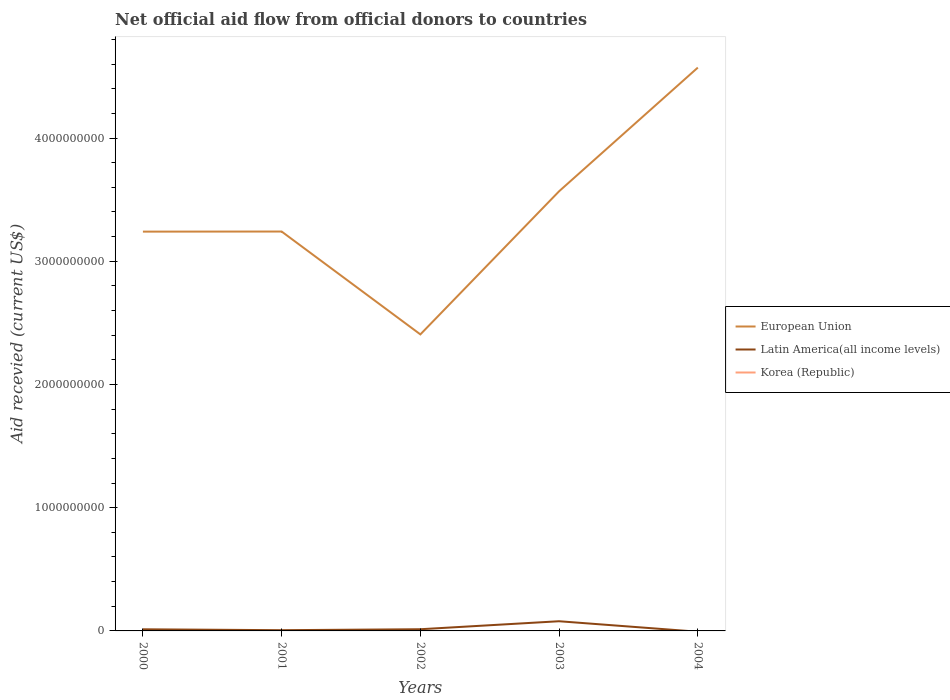Does the line corresponding to Korea (Republic) intersect with the line corresponding to European Union?
Ensure brevity in your answer.  No. Is the number of lines equal to the number of legend labels?
Your answer should be very brief. No. What is the total total aid received in European Union in the graph?
Keep it short and to the point. -1.33e+09. What is the difference between the highest and the second highest total aid received in Latin America(all income levels)?
Give a very brief answer. 7.86e+07. Is the total aid received in European Union strictly greater than the total aid received in Korea (Republic) over the years?
Your answer should be compact. No. How many lines are there?
Provide a succinct answer. 2. How many years are there in the graph?
Ensure brevity in your answer.  5. What is the difference between two consecutive major ticks on the Y-axis?
Keep it short and to the point. 1.00e+09. Are the values on the major ticks of Y-axis written in scientific E-notation?
Keep it short and to the point. No. How many legend labels are there?
Keep it short and to the point. 3. How are the legend labels stacked?
Offer a terse response. Vertical. What is the title of the graph?
Ensure brevity in your answer.  Net official aid flow from official donors to countries. Does "Thailand" appear as one of the legend labels in the graph?
Make the answer very short. No. What is the label or title of the X-axis?
Offer a very short reply. Years. What is the label or title of the Y-axis?
Provide a succinct answer. Aid recevied (current US$). What is the Aid recevied (current US$) of European Union in 2000?
Your answer should be very brief. 3.24e+09. What is the Aid recevied (current US$) of Latin America(all income levels) in 2000?
Make the answer very short. 1.31e+07. What is the Aid recevied (current US$) in European Union in 2001?
Keep it short and to the point. 3.24e+09. What is the Aid recevied (current US$) in Latin America(all income levels) in 2001?
Make the answer very short. 5.97e+06. What is the Aid recevied (current US$) in European Union in 2002?
Keep it short and to the point. 2.41e+09. What is the Aid recevied (current US$) in Latin America(all income levels) in 2002?
Make the answer very short. 1.37e+07. What is the Aid recevied (current US$) in Korea (Republic) in 2002?
Offer a terse response. 0. What is the Aid recevied (current US$) of European Union in 2003?
Your answer should be very brief. 3.57e+09. What is the Aid recevied (current US$) in Latin America(all income levels) in 2003?
Make the answer very short. 7.86e+07. What is the Aid recevied (current US$) of Korea (Republic) in 2003?
Your answer should be very brief. 0. What is the Aid recevied (current US$) of European Union in 2004?
Provide a short and direct response. 4.57e+09. What is the Aid recevied (current US$) in Latin America(all income levels) in 2004?
Provide a succinct answer. 0. What is the Aid recevied (current US$) of Korea (Republic) in 2004?
Your answer should be very brief. 0. Across all years, what is the maximum Aid recevied (current US$) of European Union?
Provide a short and direct response. 4.57e+09. Across all years, what is the maximum Aid recevied (current US$) in Latin America(all income levels)?
Ensure brevity in your answer.  7.86e+07. Across all years, what is the minimum Aid recevied (current US$) of European Union?
Give a very brief answer. 2.41e+09. What is the total Aid recevied (current US$) in European Union in the graph?
Offer a terse response. 1.70e+1. What is the total Aid recevied (current US$) in Latin America(all income levels) in the graph?
Your answer should be compact. 1.11e+08. What is the total Aid recevied (current US$) in Korea (Republic) in the graph?
Provide a short and direct response. 0. What is the difference between the Aid recevied (current US$) in European Union in 2000 and that in 2001?
Your response must be concise. -7.70e+05. What is the difference between the Aid recevied (current US$) in Latin America(all income levels) in 2000 and that in 2001?
Offer a very short reply. 7.16e+06. What is the difference between the Aid recevied (current US$) in European Union in 2000 and that in 2002?
Offer a very short reply. 8.34e+08. What is the difference between the Aid recevied (current US$) in Latin America(all income levels) in 2000 and that in 2002?
Your answer should be very brief. -5.80e+05. What is the difference between the Aid recevied (current US$) of European Union in 2000 and that in 2003?
Your answer should be very brief. -3.28e+08. What is the difference between the Aid recevied (current US$) in Latin America(all income levels) in 2000 and that in 2003?
Offer a terse response. -6.54e+07. What is the difference between the Aid recevied (current US$) in European Union in 2000 and that in 2004?
Make the answer very short. -1.33e+09. What is the difference between the Aid recevied (current US$) in European Union in 2001 and that in 2002?
Provide a succinct answer. 8.35e+08. What is the difference between the Aid recevied (current US$) of Latin America(all income levels) in 2001 and that in 2002?
Offer a very short reply. -7.74e+06. What is the difference between the Aid recevied (current US$) in European Union in 2001 and that in 2003?
Provide a short and direct response. -3.27e+08. What is the difference between the Aid recevied (current US$) in Latin America(all income levels) in 2001 and that in 2003?
Make the answer very short. -7.26e+07. What is the difference between the Aid recevied (current US$) in European Union in 2001 and that in 2004?
Give a very brief answer. -1.33e+09. What is the difference between the Aid recevied (current US$) of European Union in 2002 and that in 2003?
Your answer should be compact. -1.16e+09. What is the difference between the Aid recevied (current US$) in Latin America(all income levels) in 2002 and that in 2003?
Your response must be concise. -6.49e+07. What is the difference between the Aid recevied (current US$) of European Union in 2002 and that in 2004?
Make the answer very short. -2.17e+09. What is the difference between the Aid recevied (current US$) of European Union in 2003 and that in 2004?
Provide a succinct answer. -1.00e+09. What is the difference between the Aid recevied (current US$) in European Union in 2000 and the Aid recevied (current US$) in Latin America(all income levels) in 2001?
Provide a short and direct response. 3.23e+09. What is the difference between the Aid recevied (current US$) of European Union in 2000 and the Aid recevied (current US$) of Latin America(all income levels) in 2002?
Provide a succinct answer. 3.23e+09. What is the difference between the Aid recevied (current US$) of European Union in 2000 and the Aid recevied (current US$) of Latin America(all income levels) in 2003?
Offer a very short reply. 3.16e+09. What is the difference between the Aid recevied (current US$) of European Union in 2001 and the Aid recevied (current US$) of Latin America(all income levels) in 2002?
Offer a very short reply. 3.23e+09. What is the difference between the Aid recevied (current US$) in European Union in 2001 and the Aid recevied (current US$) in Latin America(all income levels) in 2003?
Your answer should be very brief. 3.16e+09. What is the difference between the Aid recevied (current US$) in European Union in 2002 and the Aid recevied (current US$) in Latin America(all income levels) in 2003?
Make the answer very short. 2.33e+09. What is the average Aid recevied (current US$) in European Union per year?
Provide a short and direct response. 3.41e+09. What is the average Aid recevied (current US$) in Latin America(all income levels) per year?
Offer a very short reply. 2.23e+07. In the year 2000, what is the difference between the Aid recevied (current US$) in European Union and Aid recevied (current US$) in Latin America(all income levels)?
Give a very brief answer. 3.23e+09. In the year 2001, what is the difference between the Aid recevied (current US$) in European Union and Aid recevied (current US$) in Latin America(all income levels)?
Your answer should be compact. 3.24e+09. In the year 2002, what is the difference between the Aid recevied (current US$) of European Union and Aid recevied (current US$) of Latin America(all income levels)?
Give a very brief answer. 2.39e+09. In the year 2003, what is the difference between the Aid recevied (current US$) of European Union and Aid recevied (current US$) of Latin America(all income levels)?
Offer a terse response. 3.49e+09. What is the ratio of the Aid recevied (current US$) of European Union in 2000 to that in 2001?
Offer a very short reply. 1. What is the ratio of the Aid recevied (current US$) of Latin America(all income levels) in 2000 to that in 2001?
Ensure brevity in your answer.  2.2. What is the ratio of the Aid recevied (current US$) of European Union in 2000 to that in 2002?
Your answer should be compact. 1.35. What is the ratio of the Aid recevied (current US$) in Latin America(all income levels) in 2000 to that in 2002?
Your answer should be very brief. 0.96. What is the ratio of the Aid recevied (current US$) in European Union in 2000 to that in 2003?
Keep it short and to the point. 0.91. What is the ratio of the Aid recevied (current US$) of Latin America(all income levels) in 2000 to that in 2003?
Offer a terse response. 0.17. What is the ratio of the Aid recevied (current US$) of European Union in 2000 to that in 2004?
Make the answer very short. 0.71. What is the ratio of the Aid recevied (current US$) of European Union in 2001 to that in 2002?
Provide a succinct answer. 1.35. What is the ratio of the Aid recevied (current US$) in Latin America(all income levels) in 2001 to that in 2002?
Provide a short and direct response. 0.44. What is the ratio of the Aid recevied (current US$) in European Union in 2001 to that in 2003?
Offer a terse response. 0.91. What is the ratio of the Aid recevied (current US$) in Latin America(all income levels) in 2001 to that in 2003?
Give a very brief answer. 0.08. What is the ratio of the Aid recevied (current US$) of European Union in 2001 to that in 2004?
Give a very brief answer. 0.71. What is the ratio of the Aid recevied (current US$) in European Union in 2002 to that in 2003?
Offer a very short reply. 0.67. What is the ratio of the Aid recevied (current US$) in Latin America(all income levels) in 2002 to that in 2003?
Offer a terse response. 0.17. What is the ratio of the Aid recevied (current US$) of European Union in 2002 to that in 2004?
Provide a succinct answer. 0.53. What is the ratio of the Aid recevied (current US$) in European Union in 2003 to that in 2004?
Your answer should be compact. 0.78. What is the difference between the highest and the second highest Aid recevied (current US$) of European Union?
Ensure brevity in your answer.  1.00e+09. What is the difference between the highest and the second highest Aid recevied (current US$) in Latin America(all income levels)?
Your response must be concise. 6.49e+07. What is the difference between the highest and the lowest Aid recevied (current US$) of European Union?
Ensure brevity in your answer.  2.17e+09. What is the difference between the highest and the lowest Aid recevied (current US$) of Latin America(all income levels)?
Offer a very short reply. 7.86e+07. 